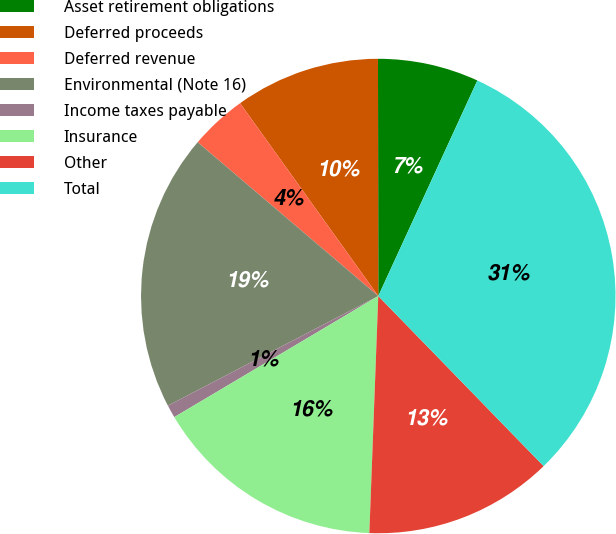Convert chart. <chart><loc_0><loc_0><loc_500><loc_500><pie_chart><fcel>Asset retirement obligations<fcel>Deferred proceeds<fcel>Deferred revenue<fcel>Environmental (Note 16)<fcel>Income taxes payable<fcel>Insurance<fcel>Other<fcel>Total<nl><fcel>6.88%<fcel>9.88%<fcel>3.88%<fcel>18.88%<fcel>0.88%<fcel>15.88%<fcel>12.88%<fcel>30.88%<nl></chart> 